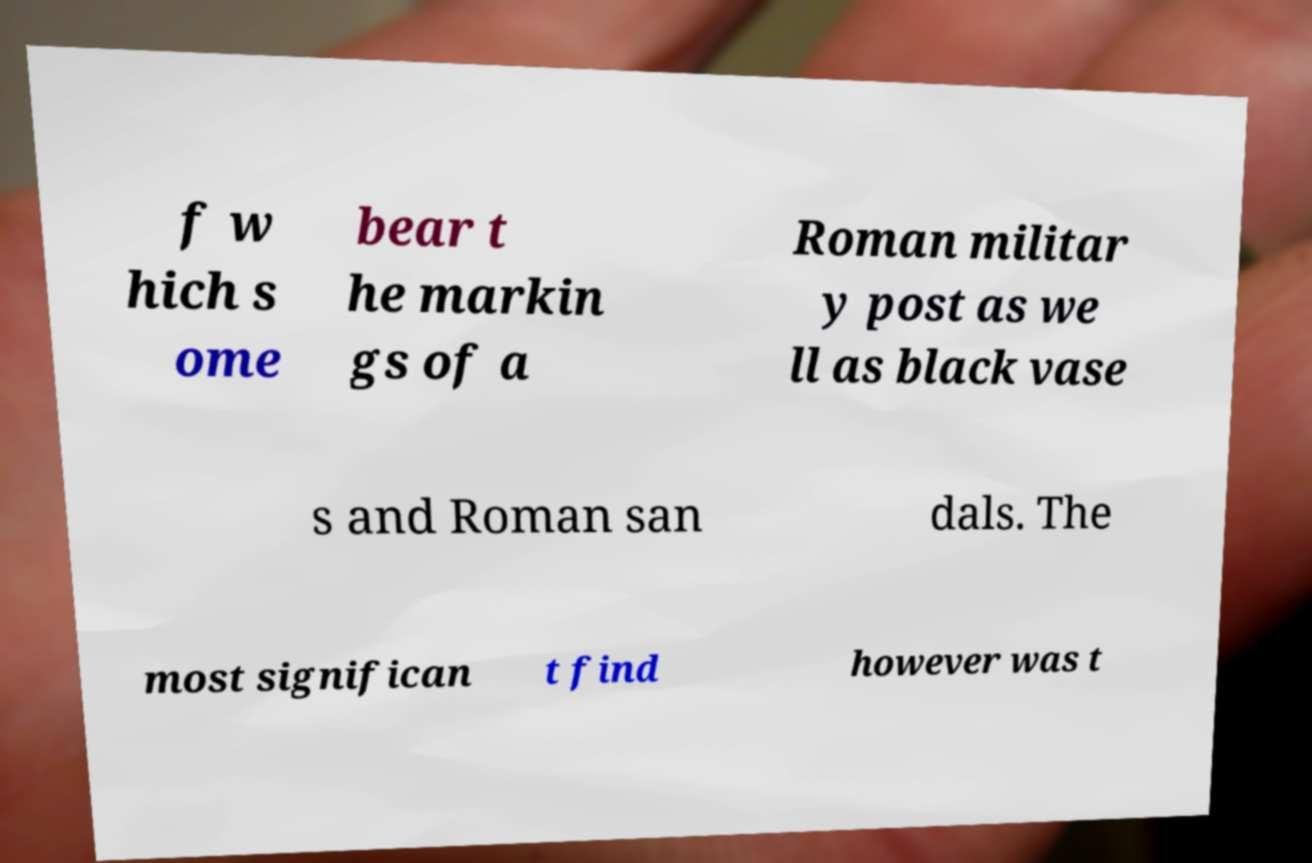What messages or text are displayed in this image? I need them in a readable, typed format. f w hich s ome bear t he markin gs of a Roman militar y post as we ll as black vase s and Roman san dals. The most significan t find however was t 